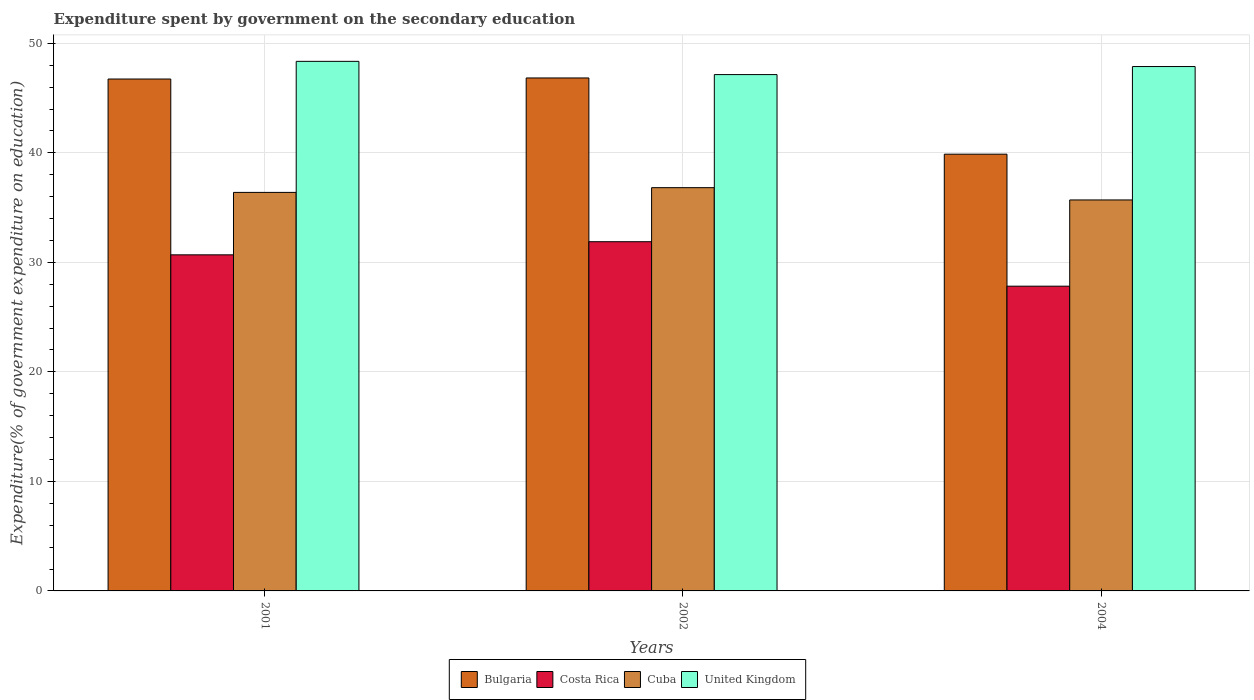How many groups of bars are there?
Give a very brief answer. 3. Are the number of bars on each tick of the X-axis equal?
Your answer should be compact. Yes. What is the label of the 1st group of bars from the left?
Your answer should be compact. 2001. In how many cases, is the number of bars for a given year not equal to the number of legend labels?
Provide a short and direct response. 0. What is the expenditure spent by government on the secondary education in Bulgaria in 2002?
Make the answer very short. 46.84. Across all years, what is the maximum expenditure spent by government on the secondary education in Costa Rica?
Give a very brief answer. 31.89. Across all years, what is the minimum expenditure spent by government on the secondary education in Cuba?
Your answer should be compact. 35.7. What is the total expenditure spent by government on the secondary education in Bulgaria in the graph?
Your answer should be very brief. 133.46. What is the difference between the expenditure spent by government on the secondary education in United Kingdom in 2001 and that in 2004?
Keep it short and to the point. 0.47. What is the difference between the expenditure spent by government on the secondary education in Cuba in 2001 and the expenditure spent by government on the secondary education in United Kingdom in 2004?
Provide a succinct answer. -11.49. What is the average expenditure spent by government on the secondary education in United Kingdom per year?
Your response must be concise. 47.8. In the year 2004, what is the difference between the expenditure spent by government on the secondary education in Cuba and expenditure spent by government on the secondary education in Costa Rica?
Offer a terse response. 7.87. What is the ratio of the expenditure spent by government on the secondary education in Cuba in 2001 to that in 2002?
Offer a very short reply. 0.99. Is the expenditure spent by government on the secondary education in Costa Rica in 2001 less than that in 2004?
Ensure brevity in your answer.  No. What is the difference between the highest and the second highest expenditure spent by government on the secondary education in Cuba?
Your answer should be compact. 0.43. What is the difference between the highest and the lowest expenditure spent by government on the secondary education in United Kingdom?
Keep it short and to the point. 1.21. Is it the case that in every year, the sum of the expenditure spent by government on the secondary education in Bulgaria and expenditure spent by government on the secondary education in Cuba is greater than the sum of expenditure spent by government on the secondary education in Costa Rica and expenditure spent by government on the secondary education in United Kingdom?
Your answer should be compact. Yes. Is it the case that in every year, the sum of the expenditure spent by government on the secondary education in Bulgaria and expenditure spent by government on the secondary education in Costa Rica is greater than the expenditure spent by government on the secondary education in United Kingdom?
Your answer should be compact. Yes. Are all the bars in the graph horizontal?
Offer a very short reply. No. Does the graph contain any zero values?
Keep it short and to the point. No. Does the graph contain grids?
Keep it short and to the point. Yes. What is the title of the graph?
Your response must be concise. Expenditure spent by government on the secondary education. What is the label or title of the Y-axis?
Offer a very short reply. Expenditure(% of government expenditure on education). What is the Expenditure(% of government expenditure on education) in Bulgaria in 2001?
Make the answer very short. 46.74. What is the Expenditure(% of government expenditure on education) in Costa Rica in 2001?
Provide a short and direct response. 30.69. What is the Expenditure(% of government expenditure on education) of Cuba in 2001?
Your response must be concise. 36.39. What is the Expenditure(% of government expenditure on education) of United Kingdom in 2001?
Your answer should be very brief. 48.36. What is the Expenditure(% of government expenditure on education) of Bulgaria in 2002?
Ensure brevity in your answer.  46.84. What is the Expenditure(% of government expenditure on education) in Costa Rica in 2002?
Provide a short and direct response. 31.89. What is the Expenditure(% of government expenditure on education) in Cuba in 2002?
Offer a terse response. 36.82. What is the Expenditure(% of government expenditure on education) in United Kingdom in 2002?
Offer a very short reply. 47.15. What is the Expenditure(% of government expenditure on education) in Bulgaria in 2004?
Offer a very short reply. 39.88. What is the Expenditure(% of government expenditure on education) in Costa Rica in 2004?
Ensure brevity in your answer.  27.83. What is the Expenditure(% of government expenditure on education) of Cuba in 2004?
Your answer should be compact. 35.7. What is the Expenditure(% of government expenditure on education) of United Kingdom in 2004?
Provide a succinct answer. 47.88. Across all years, what is the maximum Expenditure(% of government expenditure on education) in Bulgaria?
Provide a short and direct response. 46.84. Across all years, what is the maximum Expenditure(% of government expenditure on education) of Costa Rica?
Make the answer very short. 31.89. Across all years, what is the maximum Expenditure(% of government expenditure on education) of Cuba?
Give a very brief answer. 36.82. Across all years, what is the maximum Expenditure(% of government expenditure on education) in United Kingdom?
Give a very brief answer. 48.36. Across all years, what is the minimum Expenditure(% of government expenditure on education) in Bulgaria?
Your response must be concise. 39.88. Across all years, what is the minimum Expenditure(% of government expenditure on education) in Costa Rica?
Make the answer very short. 27.83. Across all years, what is the minimum Expenditure(% of government expenditure on education) of Cuba?
Provide a short and direct response. 35.7. Across all years, what is the minimum Expenditure(% of government expenditure on education) of United Kingdom?
Offer a terse response. 47.15. What is the total Expenditure(% of government expenditure on education) in Bulgaria in the graph?
Give a very brief answer. 133.46. What is the total Expenditure(% of government expenditure on education) of Costa Rica in the graph?
Offer a very short reply. 90.4. What is the total Expenditure(% of government expenditure on education) of Cuba in the graph?
Provide a succinct answer. 108.91. What is the total Expenditure(% of government expenditure on education) of United Kingdom in the graph?
Keep it short and to the point. 143.39. What is the difference between the Expenditure(% of government expenditure on education) in Bulgaria in 2001 and that in 2002?
Make the answer very short. -0.1. What is the difference between the Expenditure(% of government expenditure on education) in Costa Rica in 2001 and that in 2002?
Keep it short and to the point. -1.2. What is the difference between the Expenditure(% of government expenditure on education) of Cuba in 2001 and that in 2002?
Your response must be concise. -0.43. What is the difference between the Expenditure(% of government expenditure on education) of United Kingdom in 2001 and that in 2002?
Your answer should be compact. 1.21. What is the difference between the Expenditure(% of government expenditure on education) in Bulgaria in 2001 and that in 2004?
Offer a very short reply. 6.86. What is the difference between the Expenditure(% of government expenditure on education) in Costa Rica in 2001 and that in 2004?
Ensure brevity in your answer.  2.86. What is the difference between the Expenditure(% of government expenditure on education) in Cuba in 2001 and that in 2004?
Offer a very short reply. 0.69. What is the difference between the Expenditure(% of government expenditure on education) in United Kingdom in 2001 and that in 2004?
Offer a very short reply. 0.47. What is the difference between the Expenditure(% of government expenditure on education) in Bulgaria in 2002 and that in 2004?
Give a very brief answer. 6.96. What is the difference between the Expenditure(% of government expenditure on education) in Costa Rica in 2002 and that in 2004?
Offer a very short reply. 4.06. What is the difference between the Expenditure(% of government expenditure on education) of Cuba in 2002 and that in 2004?
Give a very brief answer. 1.12. What is the difference between the Expenditure(% of government expenditure on education) in United Kingdom in 2002 and that in 2004?
Make the answer very short. -0.73. What is the difference between the Expenditure(% of government expenditure on education) of Bulgaria in 2001 and the Expenditure(% of government expenditure on education) of Costa Rica in 2002?
Your response must be concise. 14.85. What is the difference between the Expenditure(% of government expenditure on education) in Bulgaria in 2001 and the Expenditure(% of government expenditure on education) in Cuba in 2002?
Your answer should be compact. 9.92. What is the difference between the Expenditure(% of government expenditure on education) of Bulgaria in 2001 and the Expenditure(% of government expenditure on education) of United Kingdom in 2002?
Your answer should be very brief. -0.41. What is the difference between the Expenditure(% of government expenditure on education) in Costa Rica in 2001 and the Expenditure(% of government expenditure on education) in Cuba in 2002?
Your response must be concise. -6.13. What is the difference between the Expenditure(% of government expenditure on education) in Costa Rica in 2001 and the Expenditure(% of government expenditure on education) in United Kingdom in 2002?
Offer a terse response. -16.46. What is the difference between the Expenditure(% of government expenditure on education) of Cuba in 2001 and the Expenditure(% of government expenditure on education) of United Kingdom in 2002?
Keep it short and to the point. -10.76. What is the difference between the Expenditure(% of government expenditure on education) of Bulgaria in 2001 and the Expenditure(% of government expenditure on education) of Costa Rica in 2004?
Provide a short and direct response. 18.92. What is the difference between the Expenditure(% of government expenditure on education) of Bulgaria in 2001 and the Expenditure(% of government expenditure on education) of Cuba in 2004?
Provide a succinct answer. 11.04. What is the difference between the Expenditure(% of government expenditure on education) in Bulgaria in 2001 and the Expenditure(% of government expenditure on education) in United Kingdom in 2004?
Your answer should be compact. -1.14. What is the difference between the Expenditure(% of government expenditure on education) in Costa Rica in 2001 and the Expenditure(% of government expenditure on education) in Cuba in 2004?
Your answer should be compact. -5.01. What is the difference between the Expenditure(% of government expenditure on education) of Costa Rica in 2001 and the Expenditure(% of government expenditure on education) of United Kingdom in 2004?
Offer a terse response. -17.19. What is the difference between the Expenditure(% of government expenditure on education) in Cuba in 2001 and the Expenditure(% of government expenditure on education) in United Kingdom in 2004?
Ensure brevity in your answer.  -11.49. What is the difference between the Expenditure(% of government expenditure on education) of Bulgaria in 2002 and the Expenditure(% of government expenditure on education) of Costa Rica in 2004?
Provide a succinct answer. 19.01. What is the difference between the Expenditure(% of government expenditure on education) of Bulgaria in 2002 and the Expenditure(% of government expenditure on education) of Cuba in 2004?
Offer a terse response. 11.14. What is the difference between the Expenditure(% of government expenditure on education) of Bulgaria in 2002 and the Expenditure(% of government expenditure on education) of United Kingdom in 2004?
Offer a very short reply. -1.04. What is the difference between the Expenditure(% of government expenditure on education) of Costa Rica in 2002 and the Expenditure(% of government expenditure on education) of Cuba in 2004?
Provide a succinct answer. -3.81. What is the difference between the Expenditure(% of government expenditure on education) of Costa Rica in 2002 and the Expenditure(% of government expenditure on education) of United Kingdom in 2004?
Your answer should be very brief. -15.99. What is the difference between the Expenditure(% of government expenditure on education) of Cuba in 2002 and the Expenditure(% of government expenditure on education) of United Kingdom in 2004?
Your response must be concise. -11.06. What is the average Expenditure(% of government expenditure on education) of Bulgaria per year?
Provide a short and direct response. 44.49. What is the average Expenditure(% of government expenditure on education) in Costa Rica per year?
Your answer should be compact. 30.13. What is the average Expenditure(% of government expenditure on education) in Cuba per year?
Your response must be concise. 36.3. What is the average Expenditure(% of government expenditure on education) in United Kingdom per year?
Offer a very short reply. 47.8. In the year 2001, what is the difference between the Expenditure(% of government expenditure on education) in Bulgaria and Expenditure(% of government expenditure on education) in Costa Rica?
Your answer should be compact. 16.05. In the year 2001, what is the difference between the Expenditure(% of government expenditure on education) in Bulgaria and Expenditure(% of government expenditure on education) in Cuba?
Provide a short and direct response. 10.35. In the year 2001, what is the difference between the Expenditure(% of government expenditure on education) of Bulgaria and Expenditure(% of government expenditure on education) of United Kingdom?
Offer a very short reply. -1.61. In the year 2001, what is the difference between the Expenditure(% of government expenditure on education) in Costa Rica and Expenditure(% of government expenditure on education) in Cuba?
Your response must be concise. -5.7. In the year 2001, what is the difference between the Expenditure(% of government expenditure on education) of Costa Rica and Expenditure(% of government expenditure on education) of United Kingdom?
Your response must be concise. -17.67. In the year 2001, what is the difference between the Expenditure(% of government expenditure on education) of Cuba and Expenditure(% of government expenditure on education) of United Kingdom?
Give a very brief answer. -11.97. In the year 2002, what is the difference between the Expenditure(% of government expenditure on education) of Bulgaria and Expenditure(% of government expenditure on education) of Costa Rica?
Provide a succinct answer. 14.95. In the year 2002, what is the difference between the Expenditure(% of government expenditure on education) of Bulgaria and Expenditure(% of government expenditure on education) of Cuba?
Ensure brevity in your answer.  10.02. In the year 2002, what is the difference between the Expenditure(% of government expenditure on education) of Bulgaria and Expenditure(% of government expenditure on education) of United Kingdom?
Ensure brevity in your answer.  -0.31. In the year 2002, what is the difference between the Expenditure(% of government expenditure on education) in Costa Rica and Expenditure(% of government expenditure on education) in Cuba?
Your response must be concise. -4.93. In the year 2002, what is the difference between the Expenditure(% of government expenditure on education) of Costa Rica and Expenditure(% of government expenditure on education) of United Kingdom?
Provide a short and direct response. -15.26. In the year 2002, what is the difference between the Expenditure(% of government expenditure on education) in Cuba and Expenditure(% of government expenditure on education) in United Kingdom?
Ensure brevity in your answer.  -10.33. In the year 2004, what is the difference between the Expenditure(% of government expenditure on education) in Bulgaria and Expenditure(% of government expenditure on education) in Costa Rica?
Your response must be concise. 12.05. In the year 2004, what is the difference between the Expenditure(% of government expenditure on education) of Bulgaria and Expenditure(% of government expenditure on education) of Cuba?
Provide a succinct answer. 4.18. In the year 2004, what is the difference between the Expenditure(% of government expenditure on education) of Bulgaria and Expenditure(% of government expenditure on education) of United Kingdom?
Provide a short and direct response. -8. In the year 2004, what is the difference between the Expenditure(% of government expenditure on education) in Costa Rica and Expenditure(% of government expenditure on education) in Cuba?
Ensure brevity in your answer.  -7.87. In the year 2004, what is the difference between the Expenditure(% of government expenditure on education) in Costa Rica and Expenditure(% of government expenditure on education) in United Kingdom?
Give a very brief answer. -20.05. In the year 2004, what is the difference between the Expenditure(% of government expenditure on education) of Cuba and Expenditure(% of government expenditure on education) of United Kingdom?
Your response must be concise. -12.18. What is the ratio of the Expenditure(% of government expenditure on education) in Costa Rica in 2001 to that in 2002?
Your answer should be very brief. 0.96. What is the ratio of the Expenditure(% of government expenditure on education) in Cuba in 2001 to that in 2002?
Give a very brief answer. 0.99. What is the ratio of the Expenditure(% of government expenditure on education) of United Kingdom in 2001 to that in 2002?
Your response must be concise. 1.03. What is the ratio of the Expenditure(% of government expenditure on education) in Bulgaria in 2001 to that in 2004?
Make the answer very short. 1.17. What is the ratio of the Expenditure(% of government expenditure on education) in Costa Rica in 2001 to that in 2004?
Offer a very short reply. 1.1. What is the ratio of the Expenditure(% of government expenditure on education) in Cuba in 2001 to that in 2004?
Your response must be concise. 1.02. What is the ratio of the Expenditure(% of government expenditure on education) of United Kingdom in 2001 to that in 2004?
Give a very brief answer. 1.01. What is the ratio of the Expenditure(% of government expenditure on education) of Bulgaria in 2002 to that in 2004?
Provide a short and direct response. 1.17. What is the ratio of the Expenditure(% of government expenditure on education) of Costa Rica in 2002 to that in 2004?
Ensure brevity in your answer.  1.15. What is the ratio of the Expenditure(% of government expenditure on education) in Cuba in 2002 to that in 2004?
Offer a very short reply. 1.03. What is the ratio of the Expenditure(% of government expenditure on education) in United Kingdom in 2002 to that in 2004?
Your response must be concise. 0.98. What is the difference between the highest and the second highest Expenditure(% of government expenditure on education) in Bulgaria?
Keep it short and to the point. 0.1. What is the difference between the highest and the second highest Expenditure(% of government expenditure on education) in Costa Rica?
Provide a succinct answer. 1.2. What is the difference between the highest and the second highest Expenditure(% of government expenditure on education) in Cuba?
Your response must be concise. 0.43. What is the difference between the highest and the second highest Expenditure(% of government expenditure on education) of United Kingdom?
Your answer should be very brief. 0.47. What is the difference between the highest and the lowest Expenditure(% of government expenditure on education) in Bulgaria?
Provide a succinct answer. 6.96. What is the difference between the highest and the lowest Expenditure(% of government expenditure on education) in Costa Rica?
Your answer should be very brief. 4.06. What is the difference between the highest and the lowest Expenditure(% of government expenditure on education) in Cuba?
Make the answer very short. 1.12. What is the difference between the highest and the lowest Expenditure(% of government expenditure on education) of United Kingdom?
Offer a terse response. 1.21. 